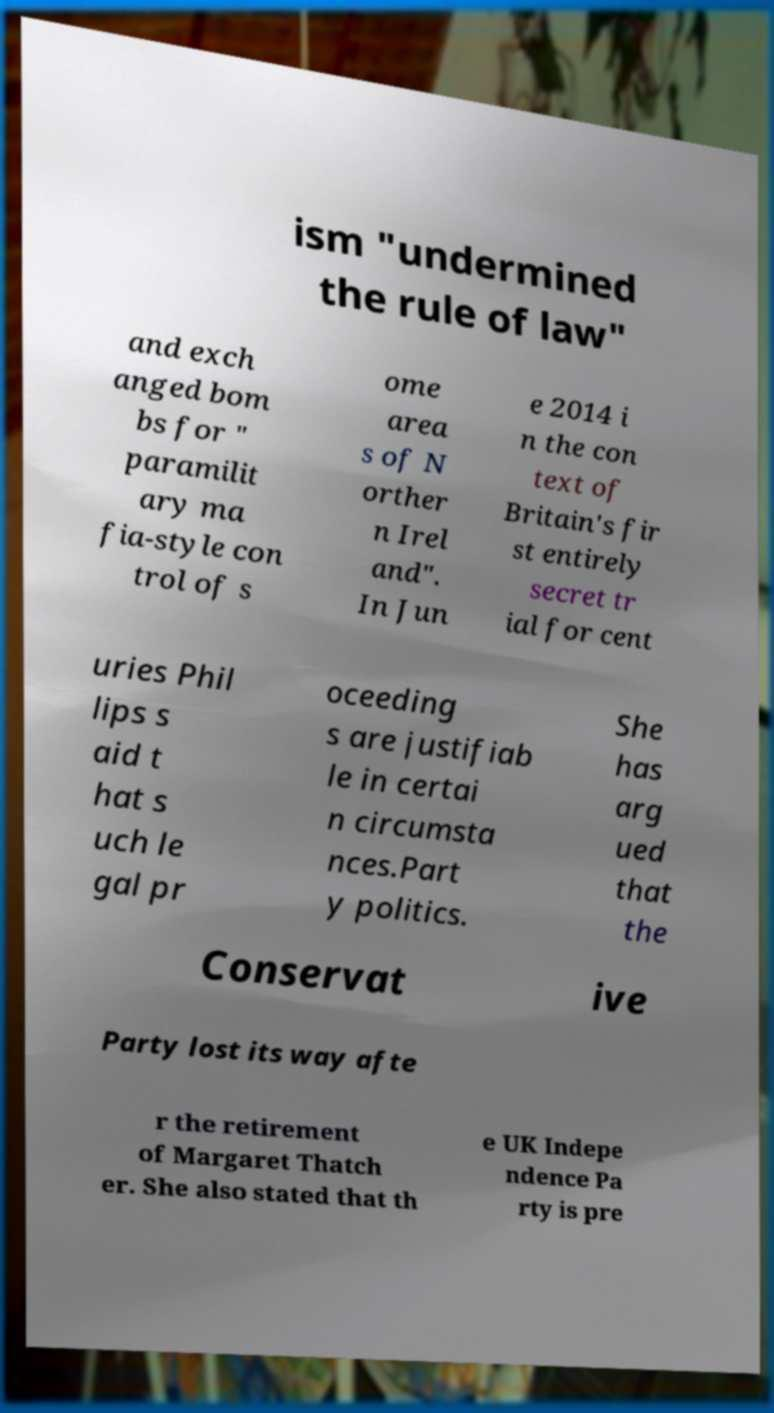For documentation purposes, I need the text within this image transcribed. Could you provide that? ism "undermined the rule of law" and exch anged bom bs for " paramilit ary ma fia-style con trol of s ome area s of N orther n Irel and". In Jun e 2014 i n the con text of Britain's fir st entirely secret tr ial for cent uries Phil lips s aid t hat s uch le gal pr oceeding s are justifiab le in certai n circumsta nces.Part y politics. She has arg ued that the Conservat ive Party lost its way afte r the retirement of Margaret Thatch er. She also stated that th e UK Indepe ndence Pa rty is pre 